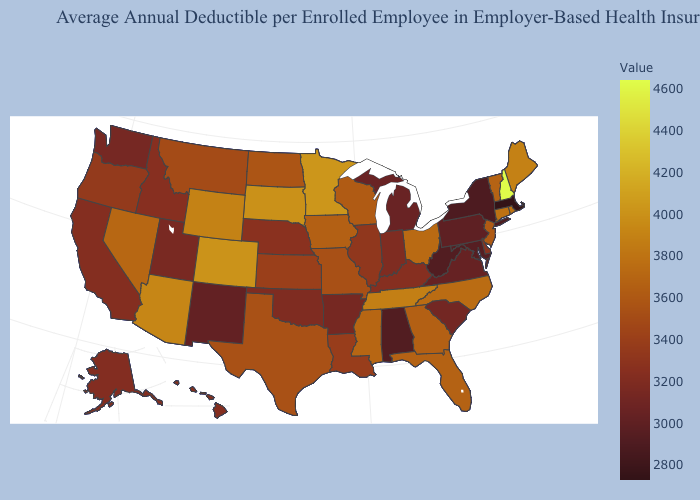Among the states that border Connecticut , does Rhode Island have the lowest value?
Write a very short answer. No. Does Minnesota have the highest value in the MidWest?
Answer briefly. Yes. Among the states that border Nevada , which have the highest value?
Concise answer only. Arizona. Does New Jersey have a higher value than Minnesota?
Be succinct. No. Is the legend a continuous bar?
Write a very short answer. Yes. 